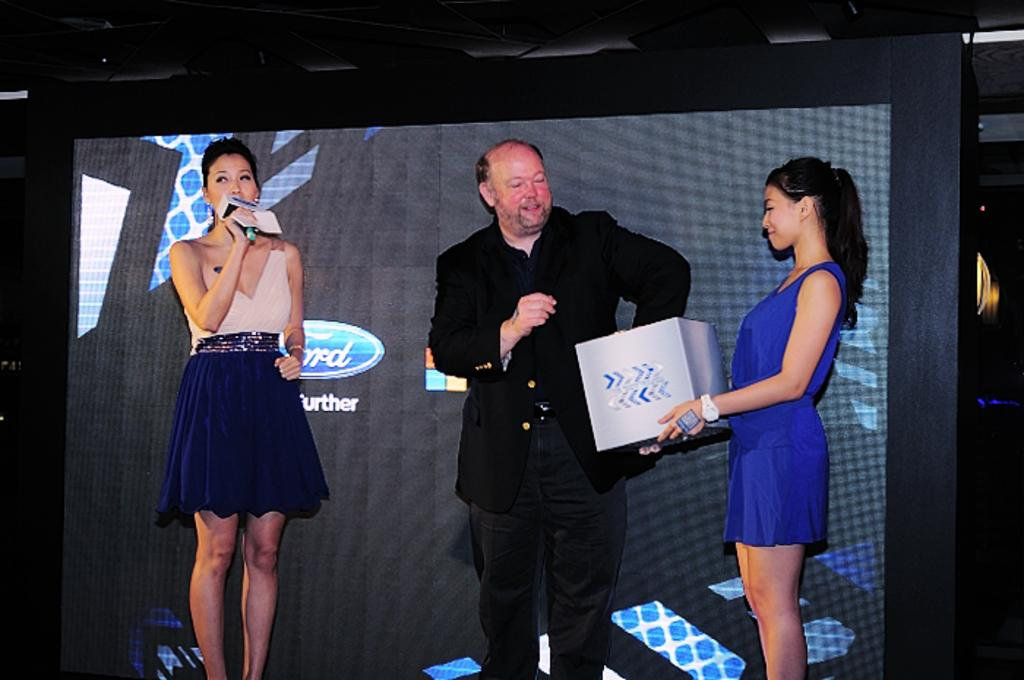How many people are in the image? There are three individuals in the image, two women and one man. Where are the individuals located in the image? The individuals are standing on the floor and are in the middle of the image. What can be seen in the background of the image? There is a screen in the background of the image. What type of stream is visible in the image? There is no stream present in the image. Are the individuals wearing stockings in the image? The provided facts do not mention anything about the individuals' clothing, so it cannot be determined if they are wearing stockings. What kind of stitch is being used by the man in the image? There is no indication in the image that the man is engaged in any activity involving stitching. 